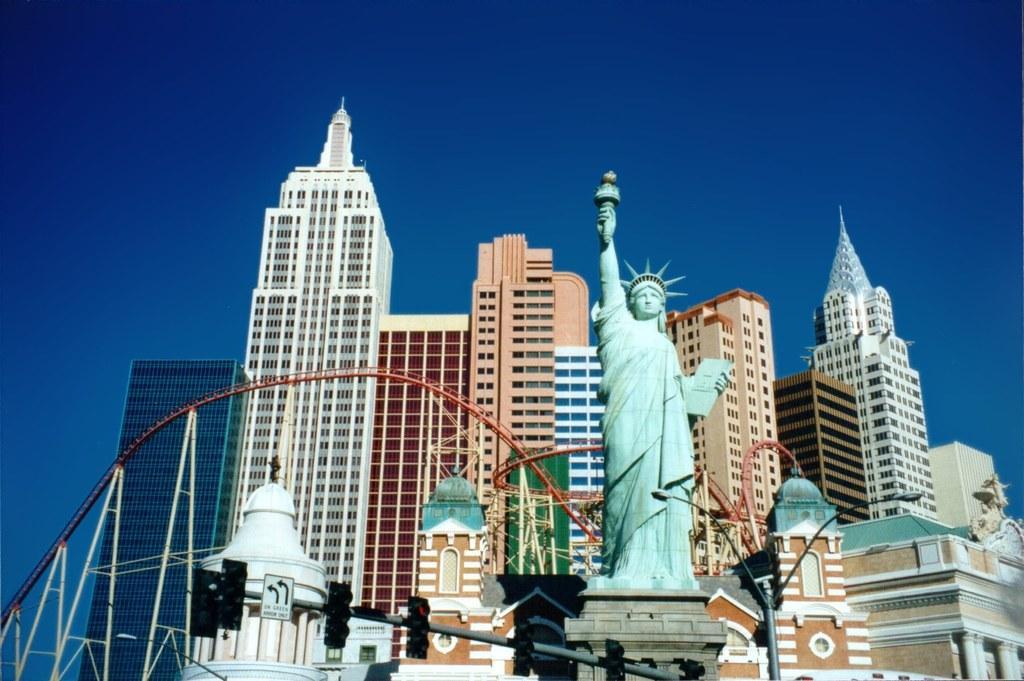Please provide a concise description of this image. In the center of the image we can see a statue of liberty. At the bottom there are traffic lights and poles. In the background there are buildings and sky. 